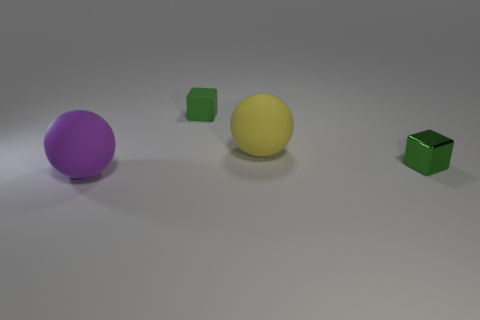Add 4 large cyan matte cylinders. How many objects exist? 8 Subtract all small green matte blocks. Subtract all matte objects. How many objects are left? 0 Add 2 large yellow things. How many large yellow things are left? 3 Add 2 small matte objects. How many small matte objects exist? 3 Subtract 0 blue spheres. How many objects are left? 4 